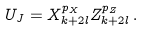Convert formula to latex. <formula><loc_0><loc_0><loc_500><loc_500>U _ { J } = X _ { k + 2 l } ^ { p _ { X } } Z _ { k + 2 l } ^ { p _ { Z } } \, .</formula> 